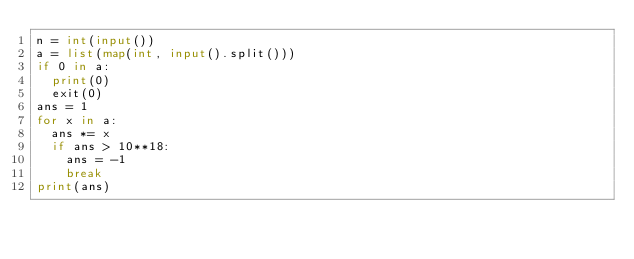<code> <loc_0><loc_0><loc_500><loc_500><_Python_>n = int(input())
a = list(map(int, input().split()))
if 0 in a:
  print(0)
  exit(0)
ans = 1
for x in a:
  ans *= x
  if ans > 10**18:
    ans = -1
    break
print(ans)</code> 